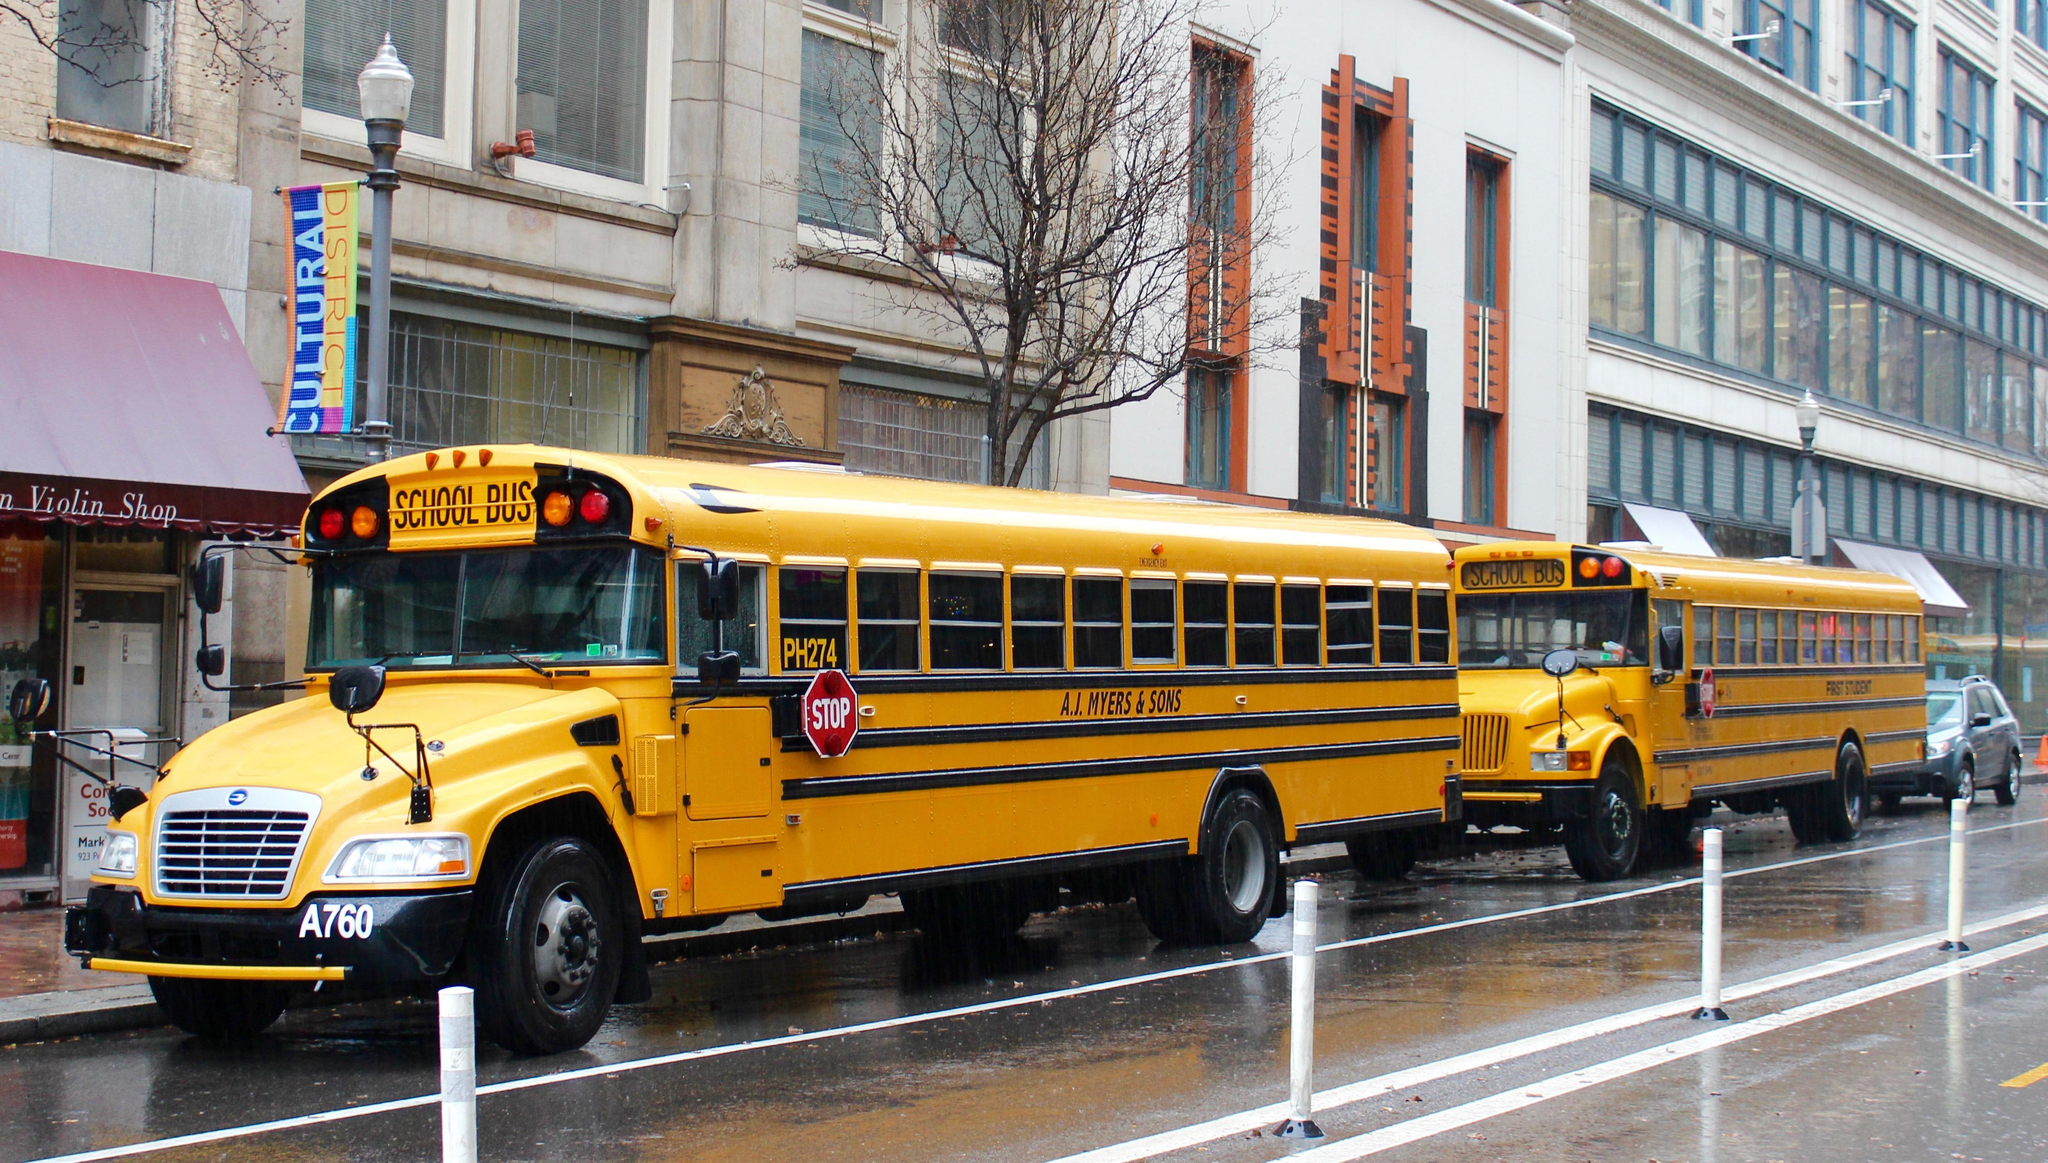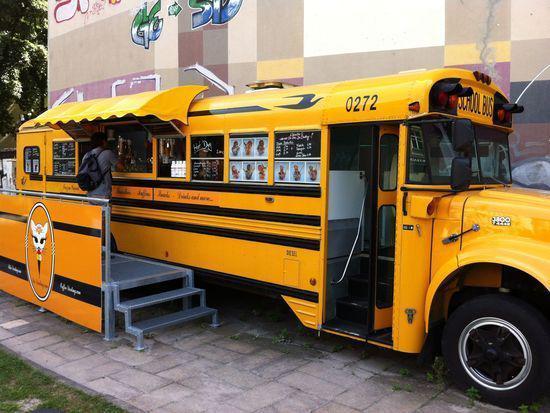The first image is the image on the left, the second image is the image on the right. Analyze the images presented: Is the assertion "One bus is a Magic School Bus and one isn't." valid? Answer yes or no. No. The first image is the image on the left, the second image is the image on the right. For the images shown, is this caption "An image includes a girl in jeans standing in front of a bus decorated with cartoon faces in the windows." true? Answer yes or no. No. 